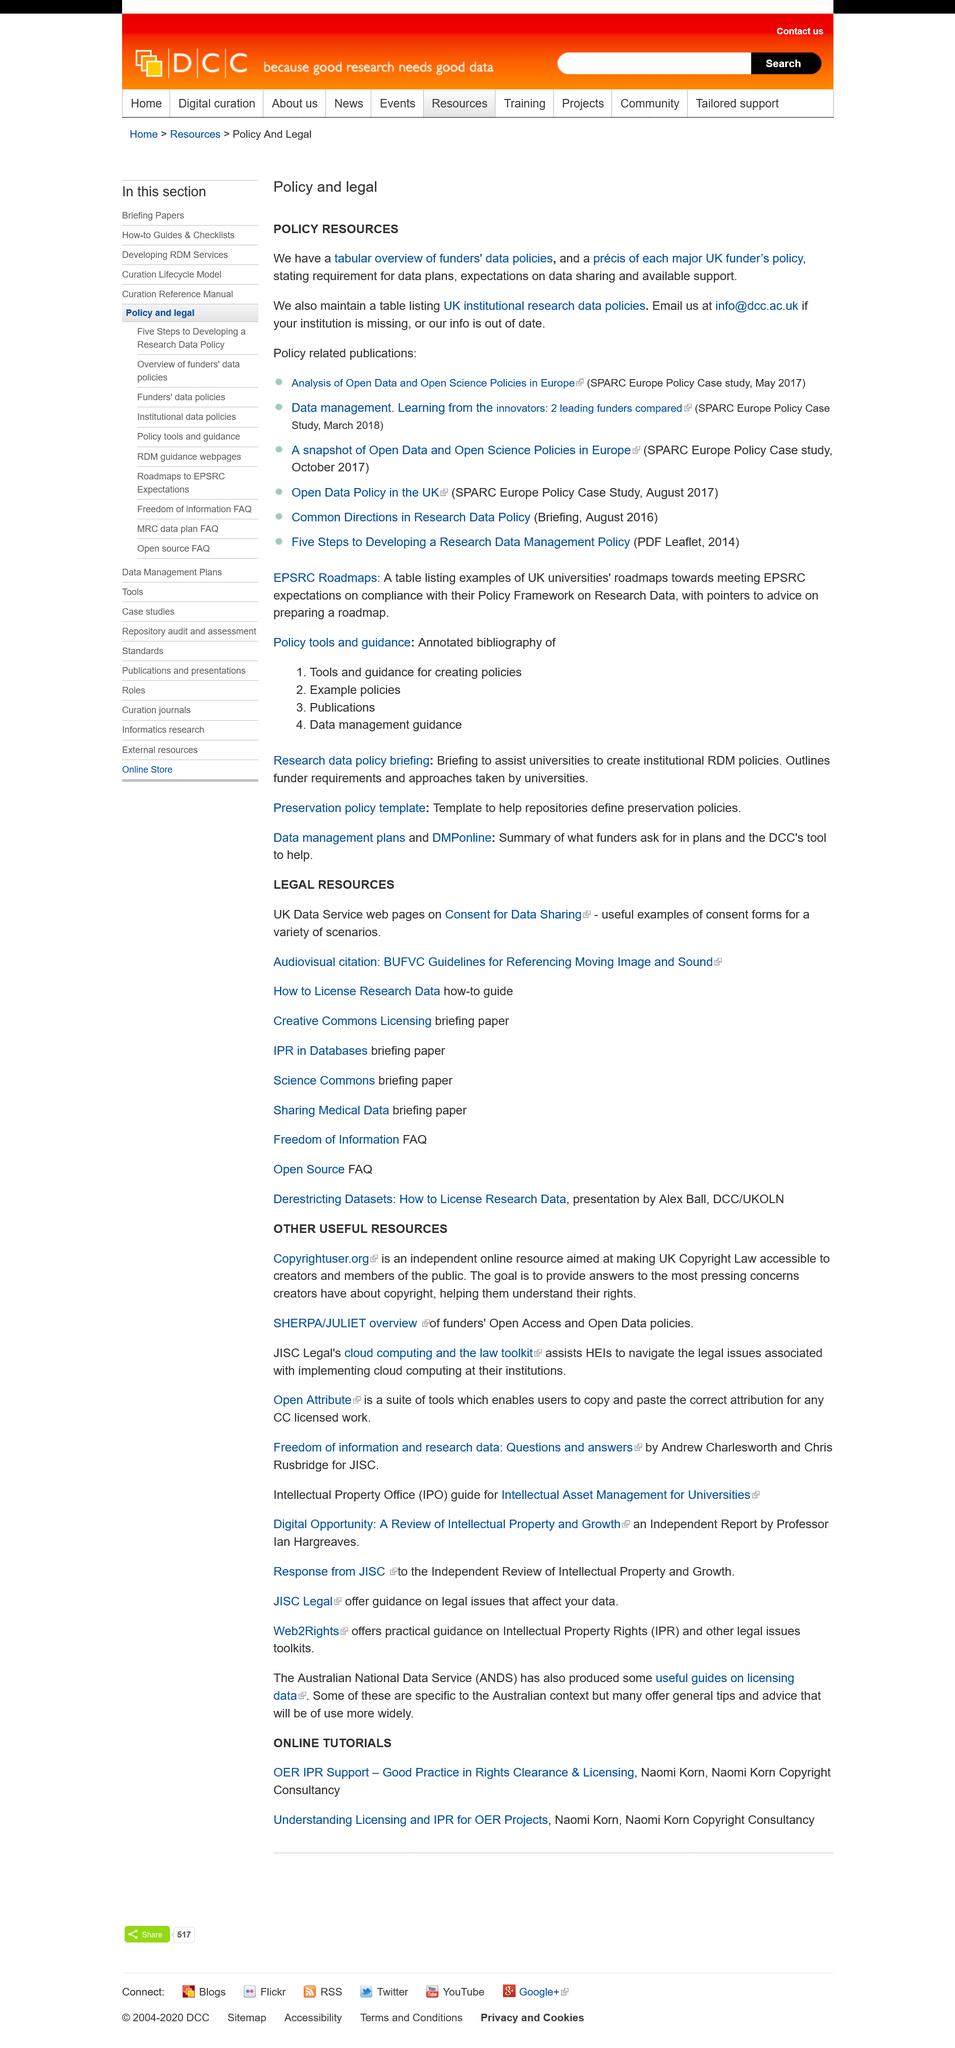Draw attention to some important aspects in this diagram. There is an e-mail address provided, and it is stated that yes, there is an e-mail address provided. The title of this page is "Policy and legal". If the information is outdated, I would email them to update it. 